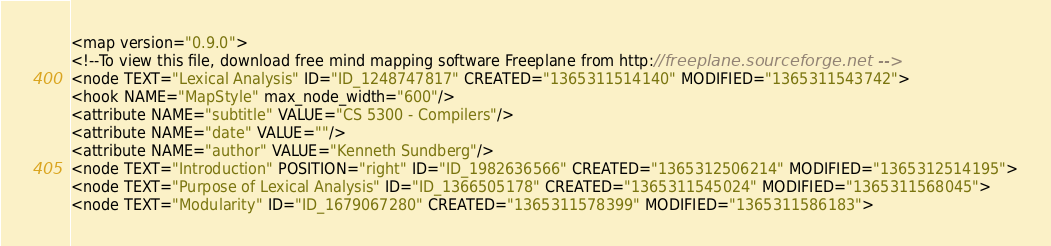Convert code to text. <code><loc_0><loc_0><loc_500><loc_500><_ObjectiveC_><map version="0.9.0">
<!--To view this file, download free mind mapping software Freeplane from http://freeplane.sourceforge.net -->
<node TEXT="Lexical Analysis" ID="ID_1248747817" CREATED="1365311514140" MODIFIED="1365311543742">
<hook NAME="MapStyle" max_node_width="600"/>
<attribute NAME="subtitle" VALUE="CS 5300 - Compilers"/>
<attribute NAME="date" VALUE=""/>
<attribute NAME="author" VALUE="Kenneth Sundberg"/>
<node TEXT="Introduction" POSITION="right" ID="ID_1982636566" CREATED="1365312506214" MODIFIED="1365312514195">
<node TEXT="Purpose of Lexical Analysis" ID="ID_1366505178" CREATED="1365311545024" MODIFIED="1365311568045">
<node TEXT="Modularity" ID="ID_1679067280" CREATED="1365311578399" MODIFIED="1365311586183"></code> 